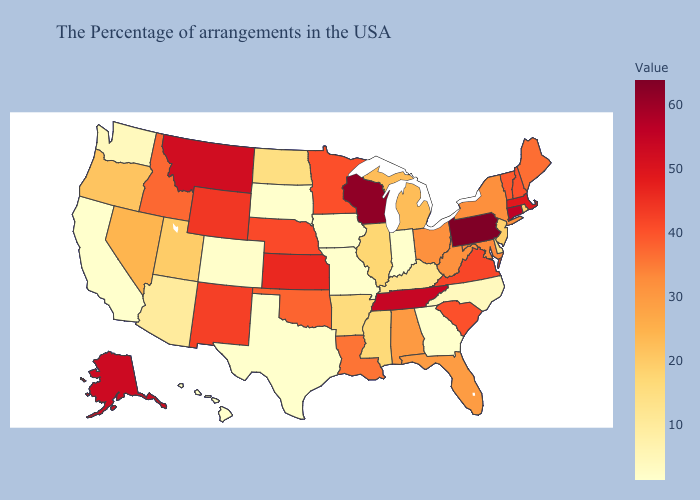Among the states that border Texas , does Louisiana have the lowest value?
Answer briefly. No. Among the states that border Texas , does Arkansas have the highest value?
Write a very short answer. No. Is the legend a continuous bar?
Concise answer only. Yes. Which states have the lowest value in the MidWest?
Short answer required. Indiana, Missouri, Iowa, South Dakota. Which states have the highest value in the USA?
Concise answer only. Pennsylvania. Does Alabama have a higher value than Delaware?
Quick response, please. Yes. Which states hav the highest value in the South?
Keep it brief. Tennessee. 